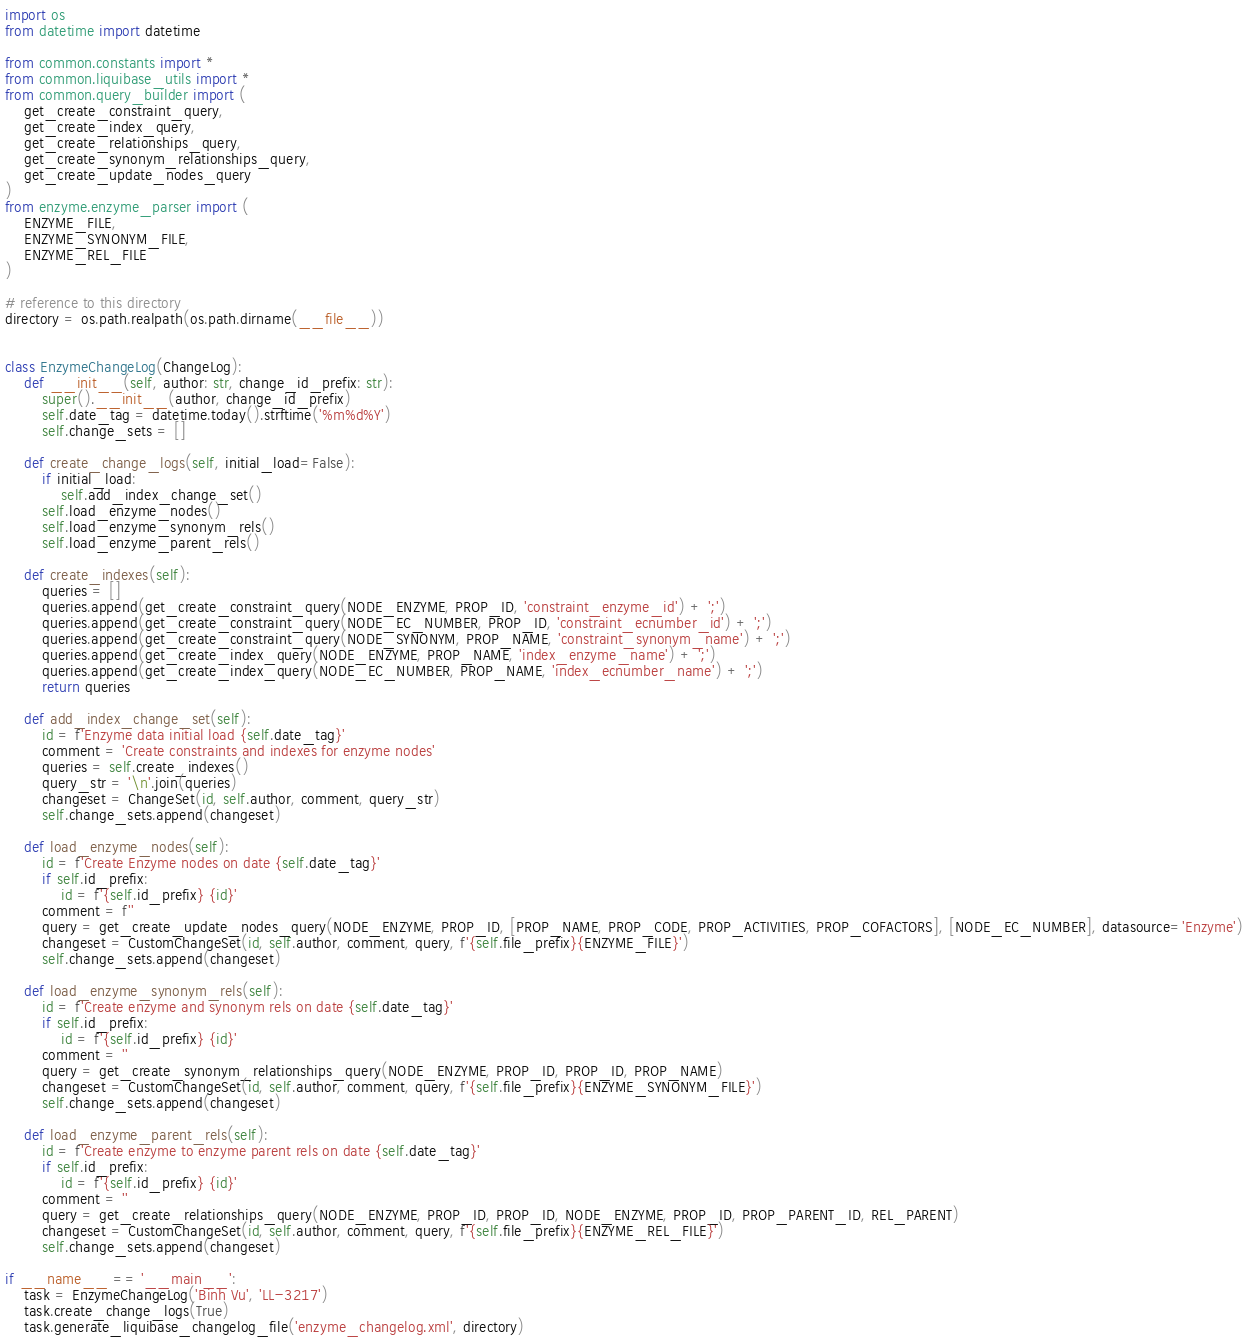<code> <loc_0><loc_0><loc_500><loc_500><_Python_>import os
from datetime import datetime

from common.constants import *
from common.liquibase_utils import *
from common.query_builder import (
    get_create_constraint_query,
    get_create_index_query,
    get_create_relationships_query,
    get_create_synonym_relationships_query,
    get_create_update_nodes_query
)
from enzyme.enzyme_parser import (
    ENZYME_FILE,
    ENZYME_SYNONYM_FILE,
    ENZYME_REL_FILE
)

# reference to this directory
directory = os.path.realpath(os.path.dirname(__file__))


class EnzymeChangeLog(ChangeLog):
    def __init__(self, author: str, change_id_prefix: str):
        super().__init__(author, change_id_prefix)
        self.date_tag = datetime.today().strftime('%m%d%Y')
        self.change_sets = []

    def create_change_logs(self, initial_load=False):
        if initial_load:
            self.add_index_change_set()
        self.load_enzyme_nodes()
        self.load_enzyme_synonym_rels()
        self.load_enzyme_parent_rels()

    def create_indexes(self):
        queries = []
        queries.append(get_create_constraint_query(NODE_ENZYME, PROP_ID, 'constraint_enzyme_id') + ';')
        queries.append(get_create_constraint_query(NODE_EC_NUMBER, PROP_ID, 'constraint_ecnumber_id') + ';')
        queries.append(get_create_constraint_query(NODE_SYNONYM, PROP_NAME, 'constraint_synonym_name') + ';')
        queries.append(get_create_index_query(NODE_ENZYME, PROP_NAME, 'index_enzyme_name') + ';')
        queries.append(get_create_index_query(NODE_EC_NUMBER, PROP_NAME, 'index_ecnumber_name') + ';')
        return queries

    def add_index_change_set(self):
        id = f'Enzyme data initial load {self.date_tag}'
        comment = 'Create constraints and indexes for enzyme nodes'
        queries = self.create_indexes()
        query_str = '\n'.join(queries)
        changeset = ChangeSet(id, self.author, comment, query_str)
        self.change_sets.append(changeset)

    def load_enzyme_nodes(self):
        id = f'Create Enzyme nodes on date {self.date_tag}'
        if self.id_prefix:
            id = f'{self.id_prefix} {id}'
        comment = f''
        query = get_create_update_nodes_query(NODE_ENZYME, PROP_ID, [PROP_NAME, PROP_CODE, PROP_ACTIVITIES, PROP_COFACTORS], [NODE_EC_NUMBER], datasource='Enzyme')
        changeset = CustomChangeSet(id, self.author, comment, query, f'{self.file_prefix}{ENZYME_FILE}')
        self.change_sets.append(changeset)

    def load_enzyme_synonym_rels(self):
        id = f'Create enzyme and synonym rels on date {self.date_tag}'
        if self.id_prefix:
            id = f'{self.id_prefix} {id}'
        comment = ''
        query = get_create_synonym_relationships_query(NODE_ENZYME, PROP_ID, PROP_ID, PROP_NAME)
        changeset = CustomChangeSet(id, self.author, comment, query, f'{self.file_prefix}{ENZYME_SYNONYM_FILE}')
        self.change_sets.append(changeset)

    def load_enzyme_parent_rels(self):
        id = f'Create enzyme to enzyme parent rels on date {self.date_tag}'
        if self.id_prefix:
            id = f'{self.id_prefix} {id}'
        comment = ''
        query = get_create_relationships_query(NODE_ENZYME, PROP_ID, PROP_ID, NODE_ENZYME, PROP_ID, PROP_PARENT_ID, REL_PARENT)
        changeset = CustomChangeSet(id, self.author, comment, query, f'{self.file_prefix}{ENZYME_REL_FILE}')
        self.change_sets.append(changeset)

if __name__ == '__main__':
    task = EnzymeChangeLog('Binh Vu', 'LL-3217')
    task.create_change_logs(True)
    task.generate_liquibase_changelog_file('enzyme_changelog.xml', directory)
</code> 